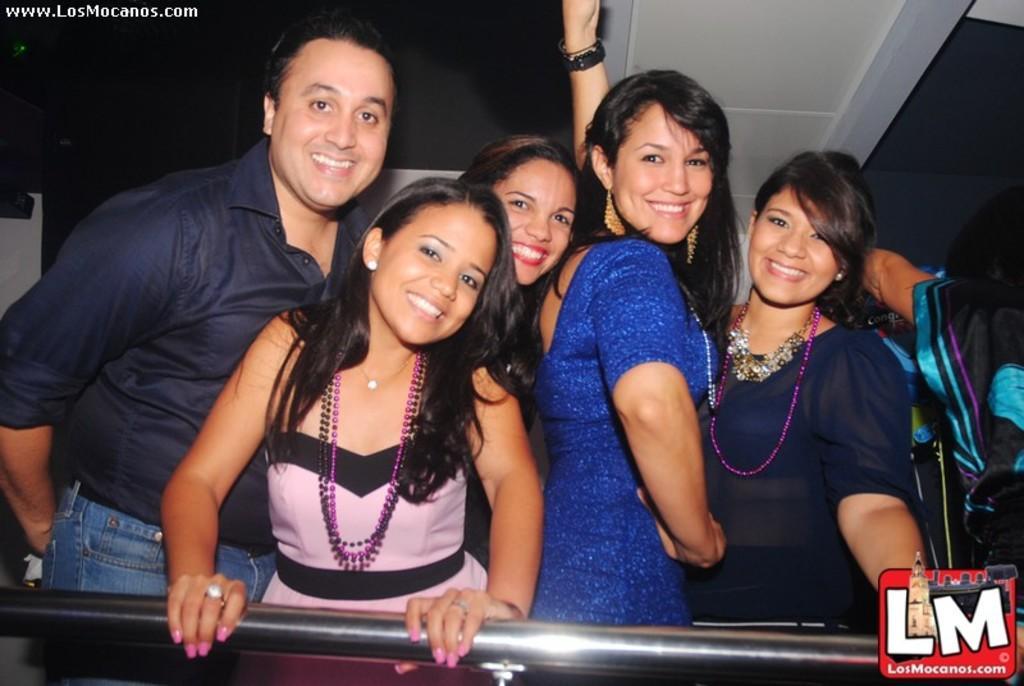Could you give a brief overview of what you see in this image? In this image I can see four women are standing and smiling and I can see a man wearing black and blue colored dress is standing and smiling. I can see a metal rod in front of them and in the background I can see the white and black colored surface. 